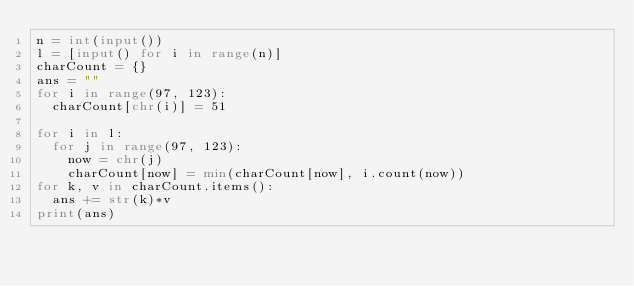<code> <loc_0><loc_0><loc_500><loc_500><_Python_>n = int(input())
l = [input() for i in range(n)]
charCount = {}
ans = ""
for i in range(97, 123):
  charCount[chr(i)] = 51

for i in l:
  for j in range(97, 123):
    now = chr(j)
    charCount[now] = min(charCount[now], i.count(now))
for k, v in charCount.items():
  ans += str(k)*v
print(ans)</code> 